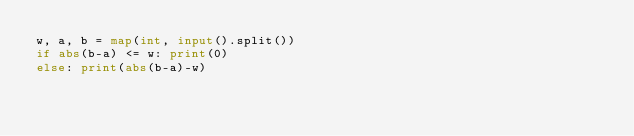Convert code to text. <code><loc_0><loc_0><loc_500><loc_500><_Python_>w, a, b = map(int, input().split())
if abs(b-a) <= w: print(0)
else: print(abs(b-a)-w)</code> 